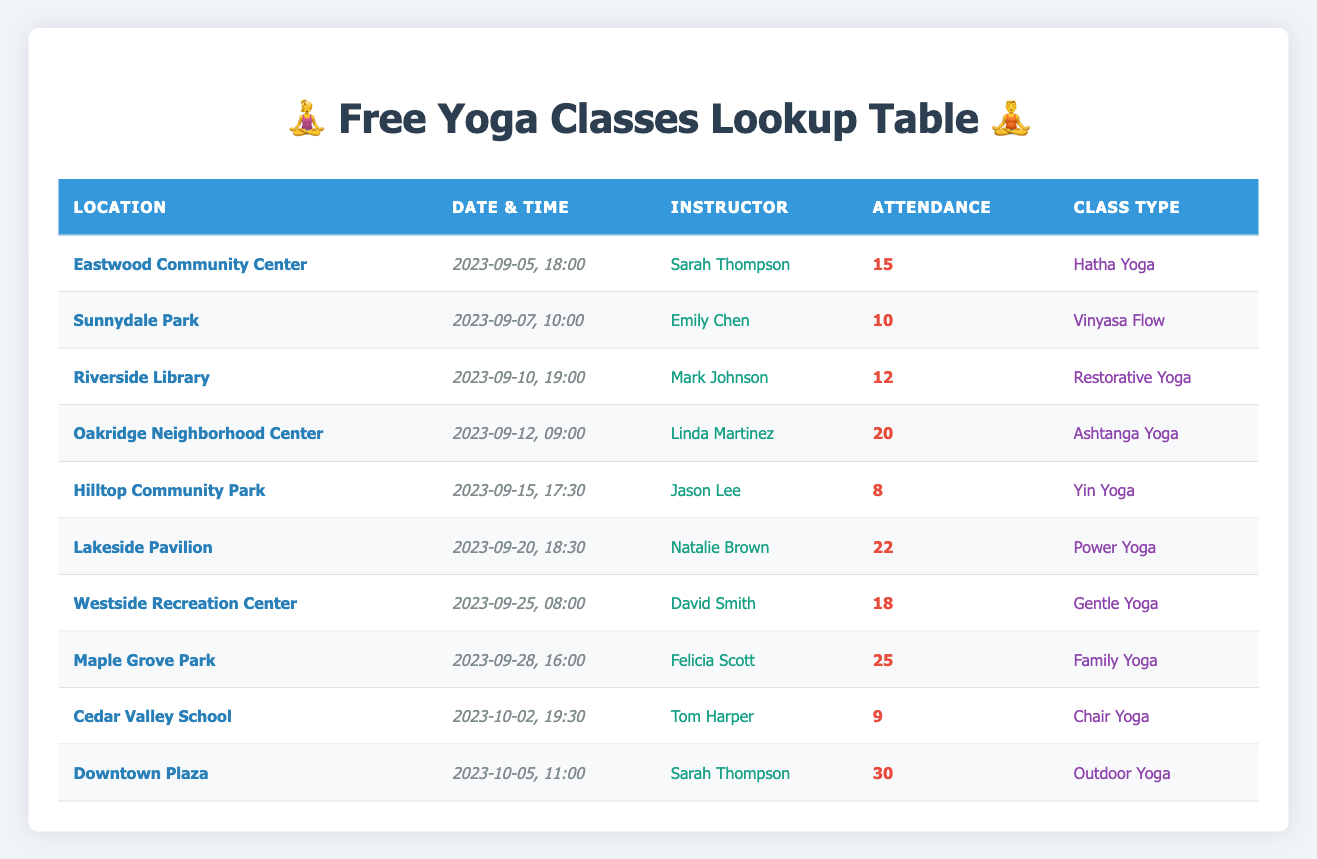What is the date and time for the yoga class at Sunnydale Park? The table lists Sunnydale Park under the location column, and the corresponding date and time is found in the date-time column. It states "2023-09-07, 10:00."
Answer: 2023-09-07, 10:00 Who is the instructor for the Hatha Yoga class? To find this, look for "Hatha Yoga" in the class type column. The corresponding instructor's name listed in that row is "Sarah Thompson."
Answer: Sarah Thompson How many people attended the yoga class on September 20th, 2023? Check the date column for "2023-09-20" and find the matching row. The attendance column indicates that there were 22 attendees.
Answer: 22 Which location had the highest attendance for a single class? Review the attendance column for the highest number from all rows. The maximum is 30, which corresponds to the class at Downtown Plaza on October 5, 2023.
Answer: Downtown Plaza What is the average attendance across all the yoga classes? First, sum the attendance numbers: (15 + 10 + 12 + 20 + 8 + 22 + 18 + 25 + 9 + 30) =  169. There are 10 classes, so to find the average, divide the total by the number of classes: 169/10 = 16.9.
Answer: 16.9 Was there any class with more than 25 attendees? Check the attendance column for any value greater than 25. The only class meeting this criterion is the one at Maple Grove Park, which had 25 attendees. The answer is no since only that class is exactly 25.
Answer: No How many classes occurred in September 2023? Count the rows with dates in September (from the date column). There are a total of 8 classes that fall within September.
Answer: 8 Which instructor had the most classes scheduled and how many were there? Review the instructor column and tally the number of classes for each instructor. Sarah Thompson leads with 2 classes.
Answer: Sarah Thompson, 2 classes What type of yoga class was conducted at Lakeside Pavilion? Find the row corresponding to "Lakeside Pavilion" in the location column. The class type listed in that row is "Power Yoga."
Answer: Power Yoga 